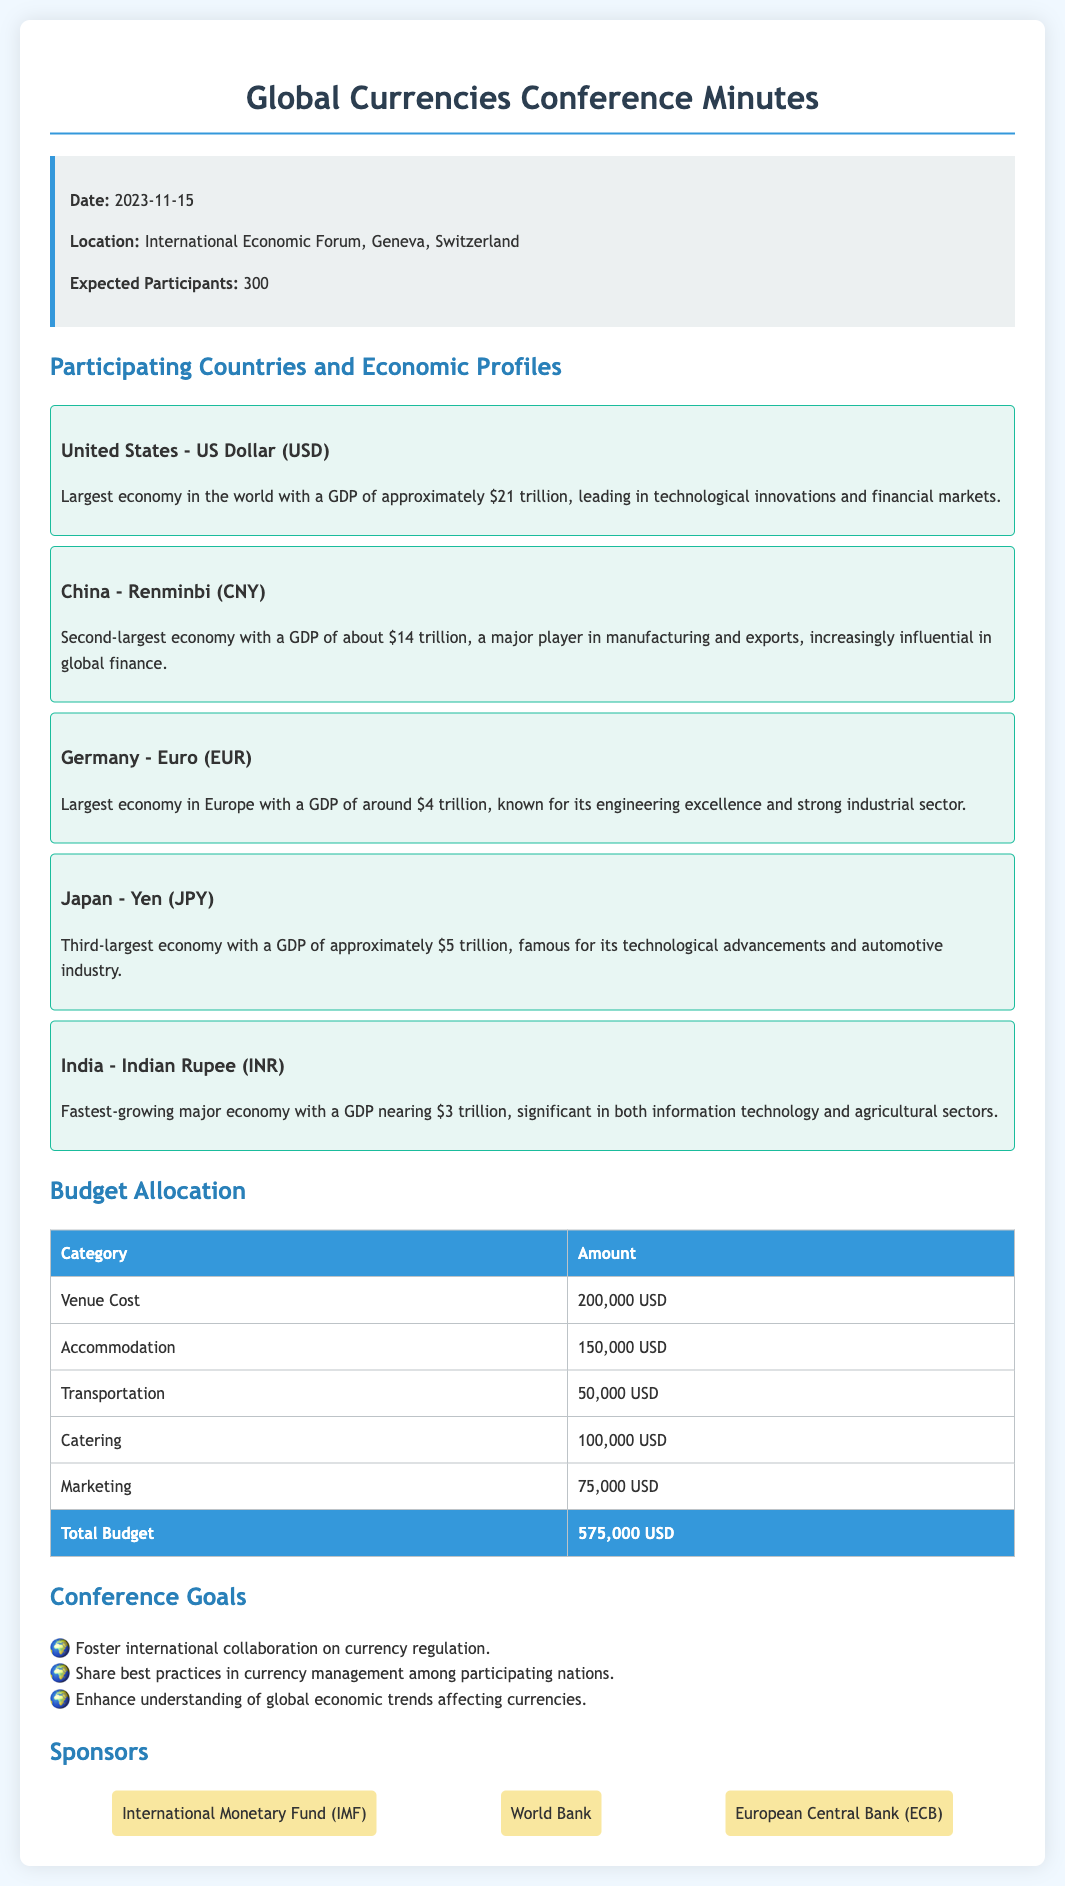What is the date of the conference? The date of the conference is specified in the document, which is November 15, 2023.
Answer: November 15, 2023 Which currency does the United States use? The currency for the United States is mentioned in the document, which is the US Dollar.
Answer: US Dollar How many expected participants are there? The expected number of participants is clearly indicated, totaling 300.
Answer: 300 What is the total budget allocated for the conference? The total budget is provided in the meeting minutes, adding up all the category amounts listed.
Answer: 575,000 USD Which country has the largest economy in the world? The document indicates that the United States has the largest economy in the world.
Answer: United States What is the main focus of the conference? The goals of the conference suggest a focus on international collaboration on currency regulation.
Answer: International collaboration on currency regulation How much is allocated for transportation? The specific allocation for transportation is defined in the budget table.
Answer: 50,000 USD Which organization is one of the sponsors listed? The sponsors of the conference are highlighted in the document, one of which is the International Monetary Fund.
Answer: International Monetary Fund 